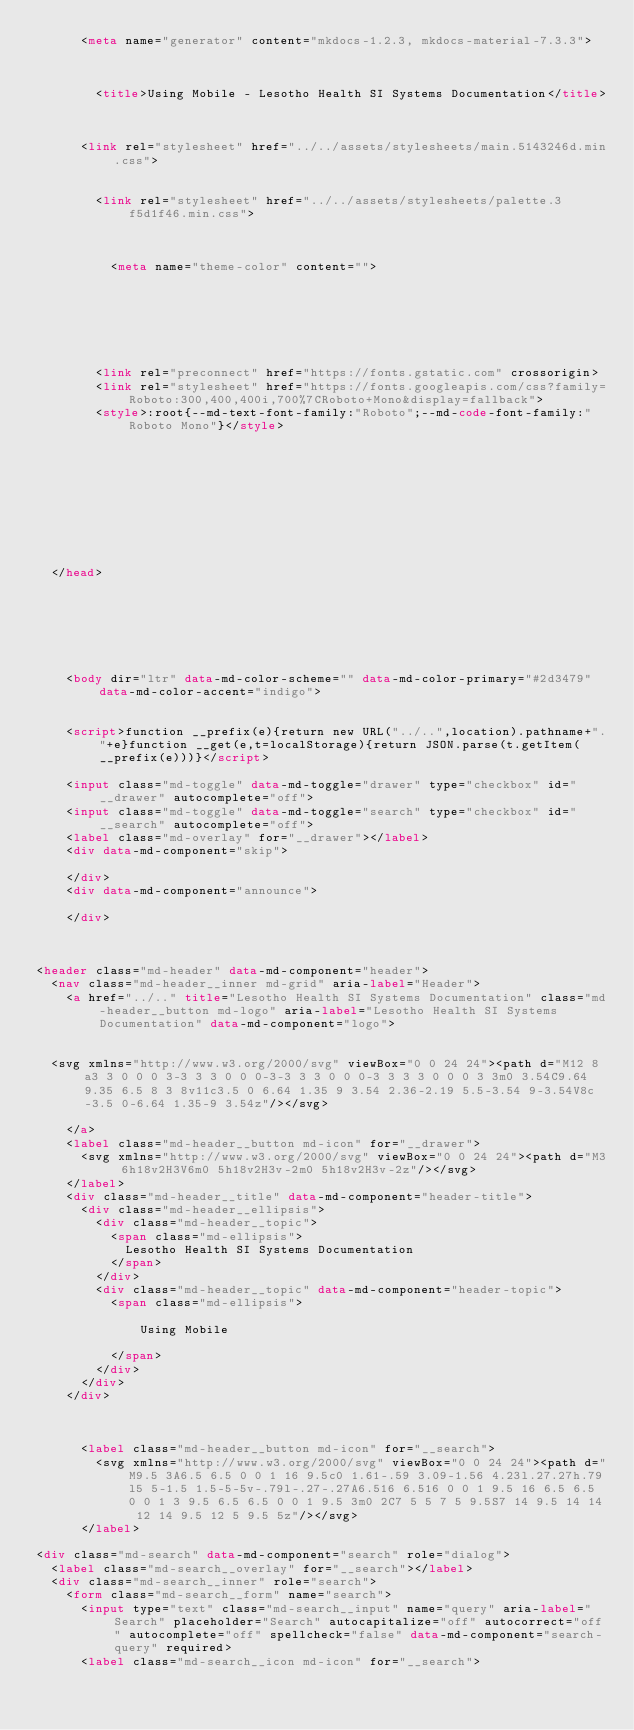Convert code to text. <code><loc_0><loc_0><loc_500><loc_500><_HTML_>      <meta name="generator" content="mkdocs-1.2.3, mkdocs-material-7.3.3">
    
    
      
        <title>Using Mobile - Lesotho Health SI Systems Documentation</title>
      
    
    
      <link rel="stylesheet" href="../../assets/stylesheets/main.5143246d.min.css">
      
        
        <link rel="stylesheet" href="../../assets/stylesheets/palette.3f5d1f46.min.css">
        
          
          
          <meta name="theme-color" content="">
        
      
    
    
    
      
        
        <link rel="preconnect" href="https://fonts.gstatic.com" crossorigin>
        <link rel="stylesheet" href="https://fonts.googleapis.com/css?family=Roboto:300,400,400i,700%7CRoboto+Mono&display=fallback">
        <style>:root{--md-text-font-family:"Roboto";--md-code-font-family:"Roboto Mono"}</style>
      
    
    
    
    
      


    
    
  </head>
  
  
    
    
    
    
    
    <body dir="ltr" data-md-color-scheme="" data-md-color-primary="#2d3479" data-md-color-accent="indigo">
  
    
    <script>function __prefix(e){return new URL("../..",location).pathname+"."+e}function __get(e,t=localStorage){return JSON.parse(t.getItem(__prefix(e)))}</script>
    
    <input class="md-toggle" data-md-toggle="drawer" type="checkbox" id="__drawer" autocomplete="off">
    <input class="md-toggle" data-md-toggle="search" type="checkbox" id="__search" autocomplete="off">
    <label class="md-overlay" for="__drawer"></label>
    <div data-md-component="skip">
      
    </div>
    <div data-md-component="announce">
      
    </div>
    
      

<header class="md-header" data-md-component="header">
  <nav class="md-header__inner md-grid" aria-label="Header">
    <a href="../.." title="Lesotho Health SI Systems Documentation" class="md-header__button md-logo" aria-label="Lesotho Health SI Systems Documentation" data-md-component="logo">
      
  
  <svg xmlns="http://www.w3.org/2000/svg" viewBox="0 0 24 24"><path d="M12 8a3 3 0 0 0 3-3 3 3 0 0 0-3-3 3 3 0 0 0-3 3 3 3 0 0 0 3 3m0 3.54C9.64 9.35 6.5 8 3 8v11c3.5 0 6.64 1.35 9 3.54 2.36-2.19 5.5-3.54 9-3.54V8c-3.5 0-6.64 1.35-9 3.54z"/></svg>

    </a>
    <label class="md-header__button md-icon" for="__drawer">
      <svg xmlns="http://www.w3.org/2000/svg" viewBox="0 0 24 24"><path d="M3 6h18v2H3V6m0 5h18v2H3v-2m0 5h18v2H3v-2z"/></svg>
    </label>
    <div class="md-header__title" data-md-component="header-title">
      <div class="md-header__ellipsis">
        <div class="md-header__topic">
          <span class="md-ellipsis">
            Lesotho Health SI Systems Documentation
          </span>
        </div>
        <div class="md-header__topic" data-md-component="header-topic">
          <span class="md-ellipsis">
            
              Using Mobile
            
          </span>
        </div>
      </div>
    </div>
    
    
    
      <label class="md-header__button md-icon" for="__search">
        <svg xmlns="http://www.w3.org/2000/svg" viewBox="0 0 24 24"><path d="M9.5 3A6.5 6.5 0 0 1 16 9.5c0 1.61-.59 3.09-1.56 4.23l.27.27h.79l5 5-1.5 1.5-5-5v-.79l-.27-.27A6.516 6.516 0 0 1 9.5 16 6.5 6.5 0 0 1 3 9.5 6.5 6.5 0 0 1 9.5 3m0 2C7 5 5 7 5 9.5S7 14 9.5 14 14 12 14 9.5 12 5 9.5 5z"/></svg>
      </label>
      
<div class="md-search" data-md-component="search" role="dialog">
  <label class="md-search__overlay" for="__search"></label>
  <div class="md-search__inner" role="search">
    <form class="md-search__form" name="search">
      <input type="text" class="md-search__input" name="query" aria-label="Search" placeholder="Search" autocapitalize="off" autocorrect="off" autocomplete="off" spellcheck="false" data-md-component="search-query" required>
      <label class="md-search__icon md-icon" for="__search"></code> 